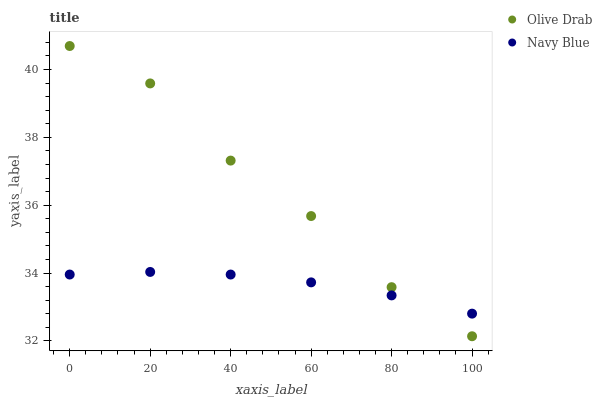Does Navy Blue have the minimum area under the curve?
Answer yes or no. Yes. Does Olive Drab have the maximum area under the curve?
Answer yes or no. Yes. Does Olive Drab have the minimum area under the curve?
Answer yes or no. No. Is Navy Blue the smoothest?
Answer yes or no. Yes. Is Olive Drab the roughest?
Answer yes or no. Yes. Is Olive Drab the smoothest?
Answer yes or no. No. Does Olive Drab have the lowest value?
Answer yes or no. Yes. Does Olive Drab have the highest value?
Answer yes or no. Yes. Does Navy Blue intersect Olive Drab?
Answer yes or no. Yes. Is Navy Blue less than Olive Drab?
Answer yes or no. No. Is Navy Blue greater than Olive Drab?
Answer yes or no. No. 